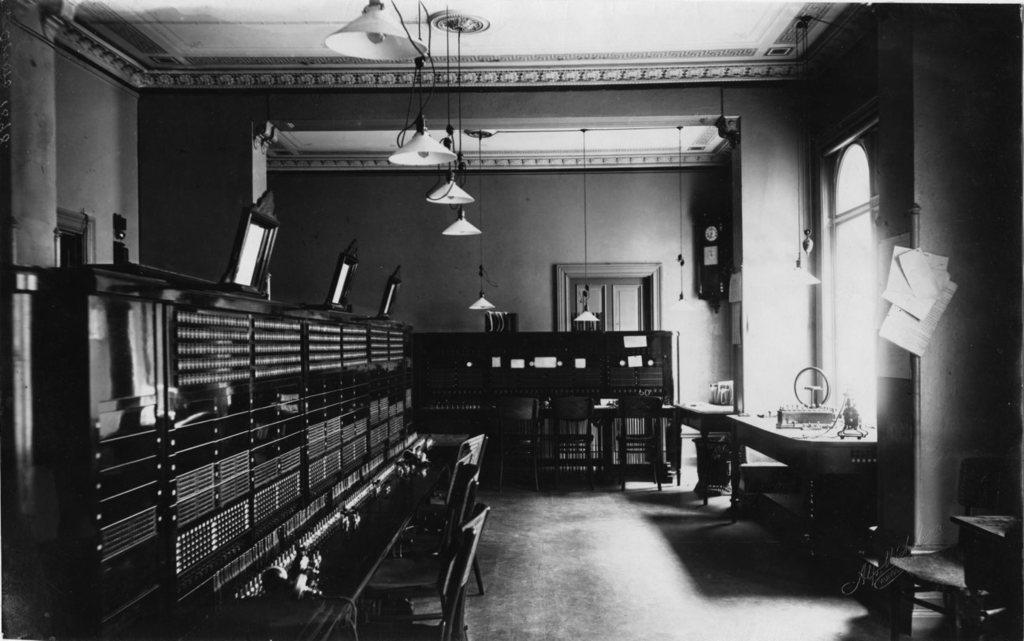In one or two sentences, can you explain what this image depicts? This is a black and white image and here we can see cupboards, chairs, boards, lights, wires, some papers which are hanging and we can see some stands and there are objects on them and there is a clock on the wall. At the bottom, there is a floor and we can see some text. 